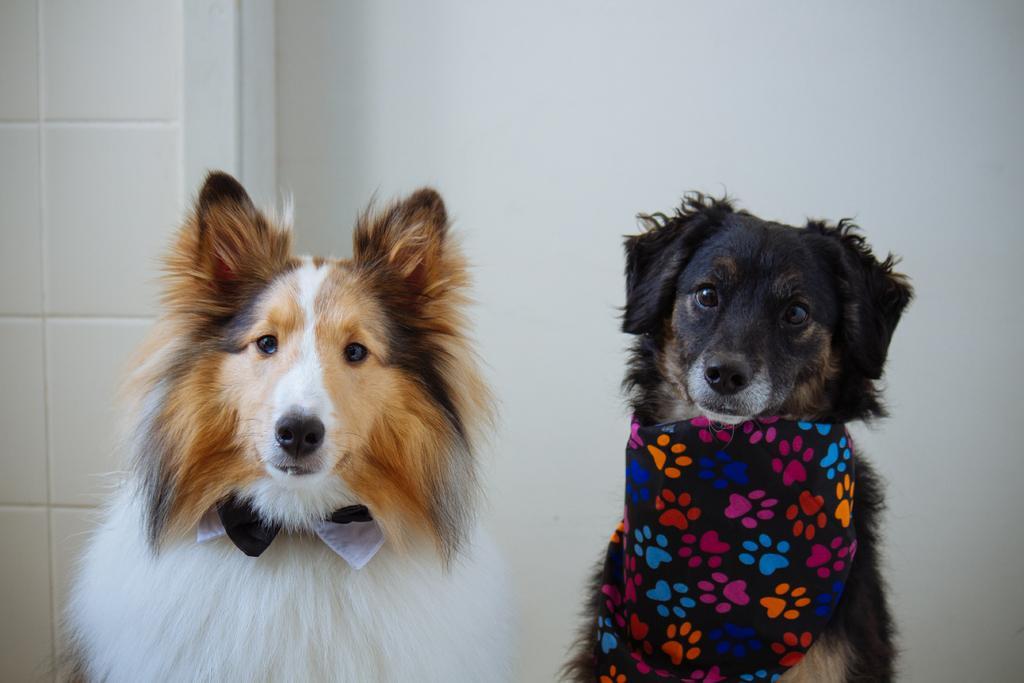Please provide a concise description of this image. Here I can see two dogs are looking at the picture. In the background there is a wall. 